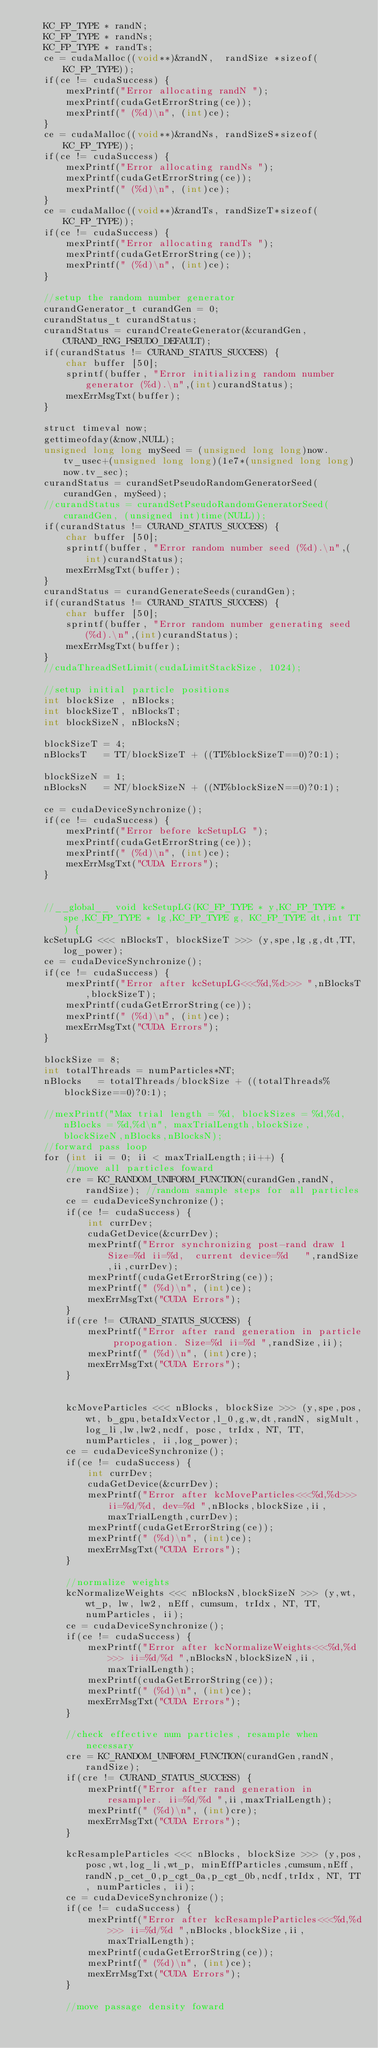Convert code to text. <code><loc_0><loc_0><loc_500><loc_500><_Cuda_>    KC_FP_TYPE * randN;
    KC_FP_TYPE * randNs;
    KC_FP_TYPE * randTs;
    ce = cudaMalloc((void**)&randN,  randSize *sizeof(KC_FP_TYPE));
    if(ce != cudaSuccess) {
        mexPrintf("Error allocating randN ");
        mexPrintf(cudaGetErrorString(ce));
        mexPrintf(" (%d)\n", (int)ce);
    }
    ce = cudaMalloc((void**)&randNs, randSizeS*sizeof(KC_FP_TYPE));
    if(ce != cudaSuccess) {
        mexPrintf("Error allocating randNs ");
        mexPrintf(cudaGetErrorString(ce));
        mexPrintf(" (%d)\n", (int)ce);
    }
    ce = cudaMalloc((void**)&randTs, randSizeT*sizeof(KC_FP_TYPE));
    if(ce != cudaSuccess) {
        mexPrintf("Error allocating randTs ");
        mexPrintf(cudaGetErrorString(ce));
        mexPrintf(" (%d)\n", (int)ce);
    }
    
    //setup the random number generator
    curandGenerator_t curandGen = 0;
    curandStatus_t curandStatus;
    curandStatus = curandCreateGenerator(&curandGen,  CURAND_RNG_PSEUDO_DEFAULT);
    if(curandStatus != CURAND_STATUS_SUCCESS) {
        char buffer [50];
        sprintf(buffer, "Error initializing random number generator (%d).\n",(int)curandStatus);
        mexErrMsgTxt(buffer);
    }

    struct timeval now;
    gettimeofday(&now,NULL);
    unsigned long long mySeed = (unsigned long long)now.tv_usec+(unsigned long long)(1e7*(unsigned long long)now.tv_sec);
    curandStatus = curandSetPseudoRandomGeneratorSeed(curandGen, mySeed);
    //curandStatus = curandSetPseudoRandomGeneratorSeed(curandGen, (unsigned int)time(NULL));
    if(curandStatus != CURAND_STATUS_SUCCESS) {
        char buffer [50];
        sprintf(buffer, "Error random number seed (%d).\n",(int)curandStatus);
        mexErrMsgTxt(buffer);
    }
    curandStatus = curandGenerateSeeds(curandGen);
    if(curandStatus != CURAND_STATUS_SUCCESS) {
        char buffer [50];
        sprintf(buffer, "Error random number generating seed (%d).\n",(int)curandStatus);
        mexErrMsgTxt(buffer);
    }
    //cudaThreadSetLimit(cudaLimitStackSize, 1024);
    
    //setup initial particle positions
    int blockSize , nBlocks;
    int blockSizeT, nBlocksT;
    int blockSizeN, nBlocksN;

    blockSizeT = 4;
    nBlocksT   = TT/blockSizeT + ((TT%blockSizeT==0)?0:1);

    blockSizeN = 1;
    nBlocksN   = NT/blockSizeN + ((NT%blockSizeN==0)?0:1);

    ce = cudaDeviceSynchronize();
    if(ce != cudaSuccess) {
        mexPrintf("Error before kcSetupLG ");
        mexPrintf(cudaGetErrorString(ce));
        mexPrintf(" (%d)\n", (int)ce);
        mexErrMsgTxt("CUDA Errors");
    }


    //__global__ void kcSetupLG(KC_FP_TYPE * y,KC_FP_TYPE * spe,KC_FP_TYPE * lg,KC_FP_TYPE g, KC_FP_TYPE dt,int TT) {
    kcSetupLG <<< nBlocksT, blockSizeT >>> (y,spe,lg,g,dt,TT,log_power);
    ce = cudaDeviceSynchronize();
    if(ce != cudaSuccess) {
        mexPrintf("Error after kcSetupLG<<<%d,%d>>> ",nBlocksT,blockSizeT);
        mexPrintf(cudaGetErrorString(ce));
        mexPrintf(" (%d)\n", (int)ce);
        mexErrMsgTxt("CUDA Errors");
    }

    blockSize = 8;
    int totalThreads = numParticles*NT;
    nBlocks   = totalThreads/blockSize + ((totalThreads%blockSize==0)?0:1);

    //mexPrintf("Max trial length = %d, blockSizes = %d,%d, nBlocks = %d,%d\n", maxTrialLength,blockSize,blockSizeN,nBlocks,nBlocksN);
    //forward pass loop
    for (int ii = 0; ii < maxTrialLength;ii++) {
        //move all particles foward
        cre = KC_RANDOM_UNIFORM_FUNCTION(curandGen,randN,randSize); //random sample steps for all particles
        ce = cudaDeviceSynchronize();
        if(ce != cudaSuccess) {
            int currDev;
            cudaGetDevice(&currDev);
            mexPrintf("Error synchronizing post-rand draw 1 Size=%d ii=%d,  current device=%d   ",randSize,ii,currDev);
            mexPrintf(cudaGetErrorString(ce));
            mexPrintf(" (%d)\n", (int)ce);
            mexErrMsgTxt("CUDA Errors");
        }
        if(cre != CURAND_STATUS_SUCCESS) {
            mexPrintf("Error after rand generation in particle propogation. Size=%d ii=%d ",randSize,ii);
            mexPrintf(" (%d)\n", (int)cre);
            mexErrMsgTxt("CUDA Errors");
        }
        

        kcMoveParticles <<< nBlocks, blockSize >>> (y,spe,pos,wt, b_gpu,betaIdxVector,l_0,g,w,dt,randN, sigMult,log_li,lw,lw2,ncdf, posc, trIdx, NT, TT, numParticles, ii,log_power);
        ce = cudaDeviceSynchronize();
        if(ce != cudaSuccess) {
            int currDev;
            cudaGetDevice(&currDev);
            mexPrintf("Error after kcMoveParticles<<<%d,%d>>> ii=%d/%d, dev=%d ",nBlocks,blockSize,ii,maxTrialLength,currDev);
            mexPrintf(cudaGetErrorString(ce));
            mexPrintf(" (%d)\n", (int)ce);
            mexErrMsgTxt("CUDA Errors");
        }

        //normalize weights
        kcNormalizeWeights <<< nBlocksN,blockSizeN >>> (y,wt,wt_p, lw, lw2, nEff, cumsum, trIdx, NT, TT, numParticles, ii);
        ce = cudaDeviceSynchronize();
        if(ce != cudaSuccess) {
            mexPrintf("Error after kcNormalizeWeights<<<%d,%d>>> ii=%d/%d ",nBlocksN,blockSizeN,ii,maxTrialLength);
            mexPrintf(cudaGetErrorString(ce));
            mexPrintf(" (%d)\n", (int)ce);
            mexErrMsgTxt("CUDA Errors");
        }

        //check effective num particles, resample when necessary
        cre = KC_RANDOM_UNIFORM_FUNCTION(curandGen,randN, randSize);
        if(cre != CURAND_STATUS_SUCCESS) {
            mexPrintf("Error after rand generation in resampler. ii=%d/%d ",ii,maxTrialLength);
            mexPrintf(" (%d)\n", (int)cre);
            mexErrMsgTxt("CUDA Errors");
        }

        kcResampleParticles <<< nBlocks, blockSize >>> (y,pos,posc,wt,log_li,wt_p, minEffParticles,cumsum,nEff,randN,p_cet_0,p_cgt_0a,p_cgt_0b,ncdf,trIdx, NT, TT, numParticles, ii); 
        ce = cudaDeviceSynchronize();
        if(ce != cudaSuccess) {
            mexPrintf("Error after kcResampleParticles<<<%d,%d>>> ii=%d/%d ",nBlocks,blockSize,ii,maxTrialLength);
            mexPrintf(cudaGetErrorString(ce));
            mexPrintf(" (%d)\n", (int)ce);
            mexErrMsgTxt("CUDA Errors");
        }

        //move passage density foward</code> 